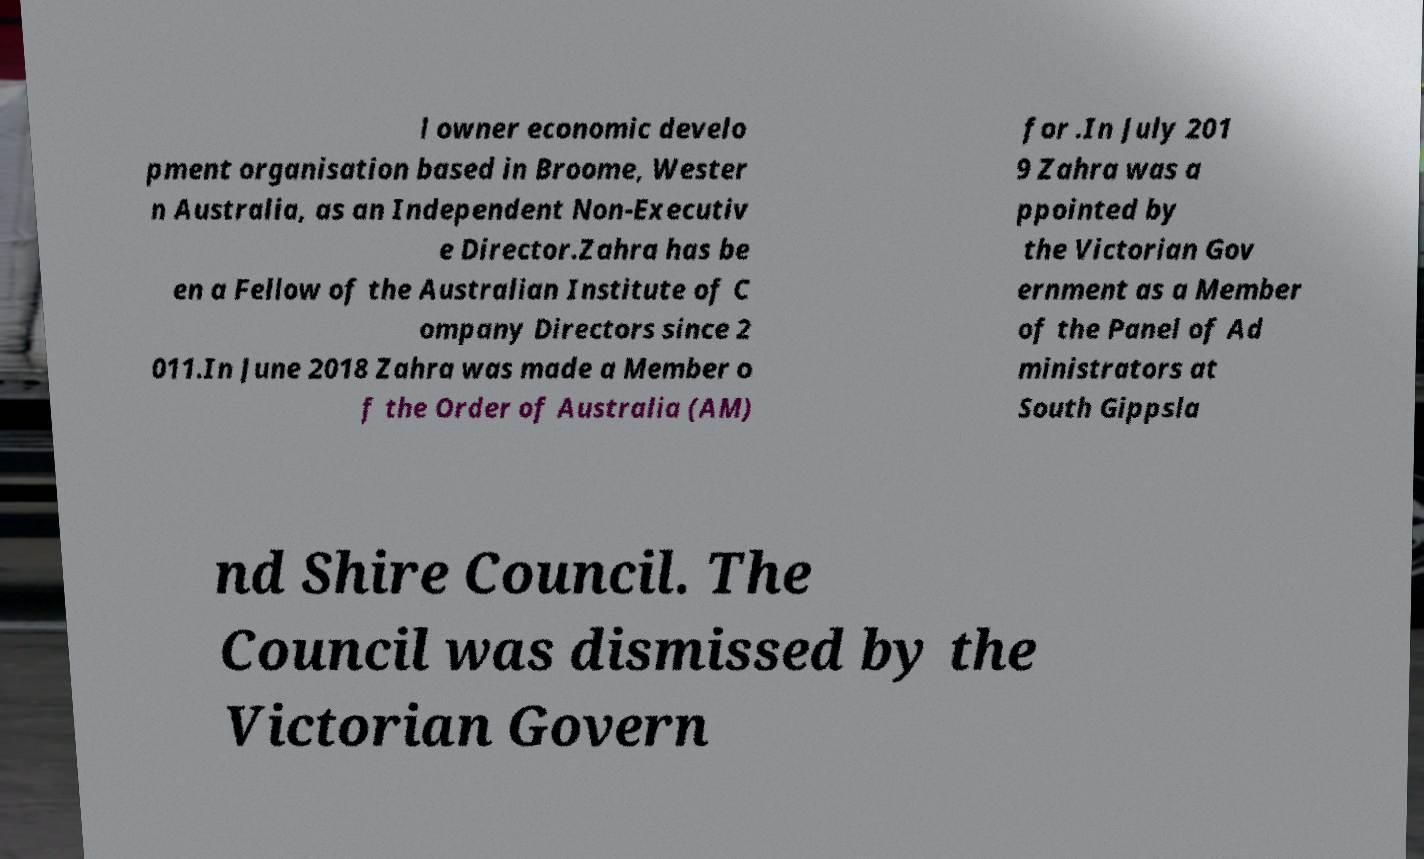What messages or text are displayed in this image? I need them in a readable, typed format. l owner economic develo pment organisation based in Broome, Wester n Australia, as an Independent Non-Executiv e Director.Zahra has be en a Fellow of the Australian Institute of C ompany Directors since 2 011.In June 2018 Zahra was made a Member o f the Order of Australia (AM) for .In July 201 9 Zahra was a ppointed by the Victorian Gov ernment as a Member of the Panel of Ad ministrators at South Gippsla nd Shire Council. The Council was dismissed by the Victorian Govern 